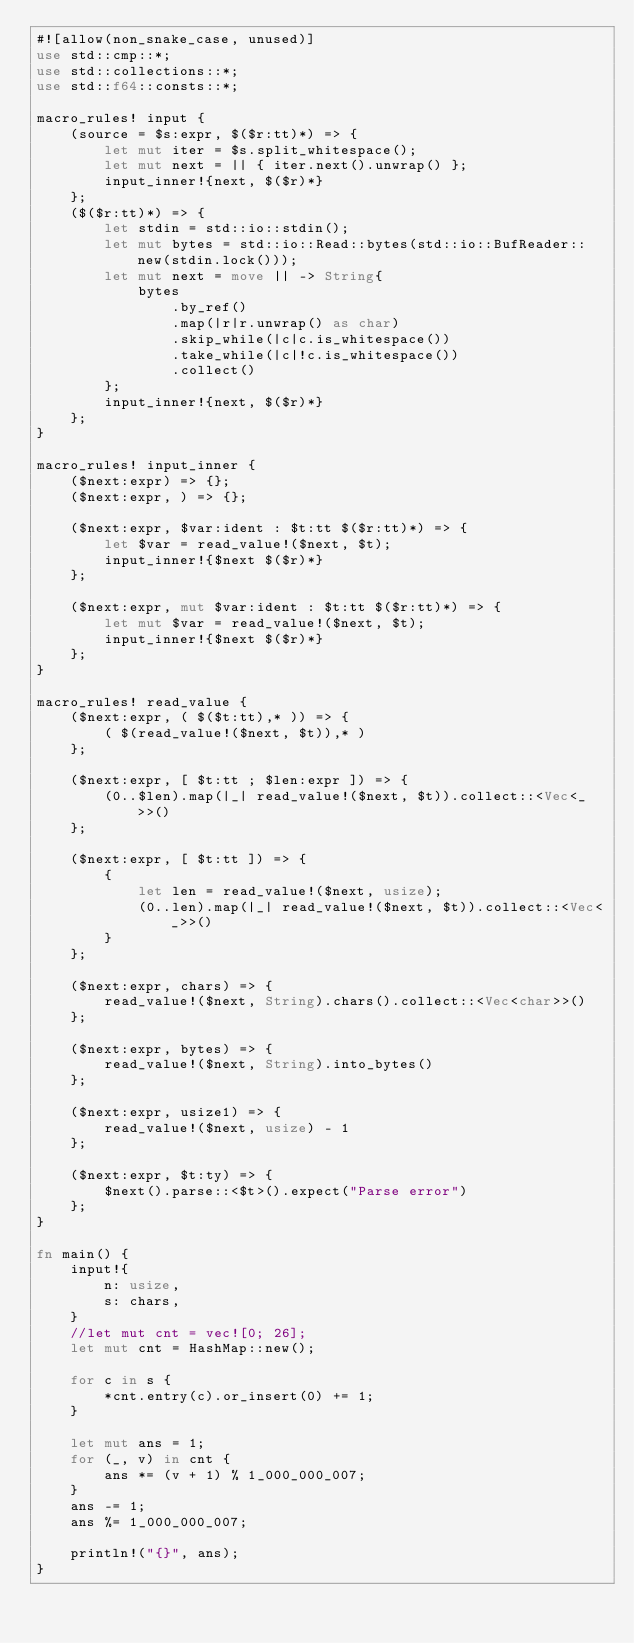<code> <loc_0><loc_0><loc_500><loc_500><_Rust_>#![allow(non_snake_case, unused)]
use std::cmp::*;
use std::collections::*;
use std::f64::consts::*;

macro_rules! input {
    (source = $s:expr, $($r:tt)*) => {
        let mut iter = $s.split_whitespace();
        let mut next = || { iter.next().unwrap() };
        input_inner!{next, $($r)*}
    };
    ($($r:tt)*) => {
        let stdin = std::io::stdin();
        let mut bytes = std::io::Read::bytes(std::io::BufReader::new(stdin.lock()));
        let mut next = move || -> String{
            bytes
                .by_ref()
                .map(|r|r.unwrap() as char)
                .skip_while(|c|c.is_whitespace())
                .take_while(|c|!c.is_whitespace())
                .collect()
        };
        input_inner!{next, $($r)*}
    };
}

macro_rules! input_inner {
    ($next:expr) => {};
    ($next:expr, ) => {};

    ($next:expr, $var:ident : $t:tt $($r:tt)*) => {
        let $var = read_value!($next, $t);
        input_inner!{$next $($r)*}
    };

    ($next:expr, mut $var:ident : $t:tt $($r:tt)*) => {
        let mut $var = read_value!($next, $t);
        input_inner!{$next $($r)*}
    };
}

macro_rules! read_value {
    ($next:expr, ( $($t:tt),* )) => {
        ( $(read_value!($next, $t)),* )
    };

    ($next:expr, [ $t:tt ; $len:expr ]) => {
        (0..$len).map(|_| read_value!($next, $t)).collect::<Vec<_>>()
    };

    ($next:expr, [ $t:tt ]) => {
        {
            let len = read_value!($next, usize);
            (0..len).map(|_| read_value!($next, $t)).collect::<Vec<_>>()
        }
    };

    ($next:expr, chars) => {
        read_value!($next, String).chars().collect::<Vec<char>>()
    };

    ($next:expr, bytes) => {
        read_value!($next, String).into_bytes()
    };

    ($next:expr, usize1) => {
        read_value!($next, usize) - 1
    };

    ($next:expr, $t:ty) => {
        $next().parse::<$t>().expect("Parse error")
    };
}

fn main() {
    input!{
        n: usize,
        s: chars,
    }
    //let mut cnt = vec![0; 26];
    let mut cnt = HashMap::new();

    for c in s {
        *cnt.entry(c).or_insert(0) += 1;
    }

    let mut ans = 1;
    for (_, v) in cnt {
        ans *= (v + 1) % 1_000_000_007;
    }
    ans -= 1;
    ans %= 1_000_000_007;

    println!("{}", ans);
}
</code> 